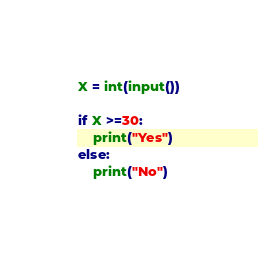Convert code to text. <code><loc_0><loc_0><loc_500><loc_500><_Python_>X = int(input())

if X >=30:
    print("Yes")
else:
    print("No")</code> 